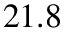<formula> <loc_0><loc_0><loc_500><loc_500>2 1 . 8</formula> 